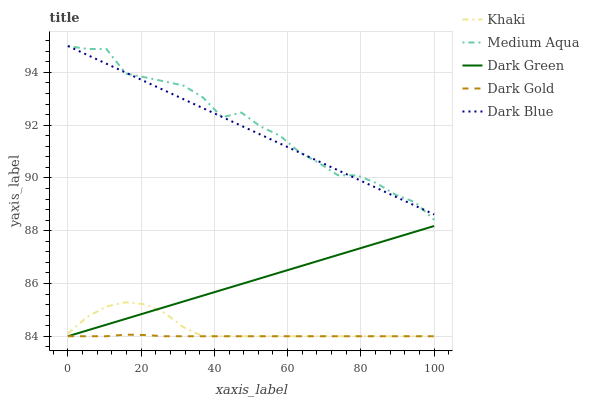Does Dark Gold have the minimum area under the curve?
Answer yes or no. Yes. Does Medium Aqua have the maximum area under the curve?
Answer yes or no. Yes. Does Khaki have the minimum area under the curve?
Answer yes or no. No. Does Khaki have the maximum area under the curve?
Answer yes or no. No. Is Dark Green the smoothest?
Answer yes or no. Yes. Is Medium Aqua the roughest?
Answer yes or no. Yes. Is Khaki the smoothest?
Answer yes or no. No. Is Khaki the roughest?
Answer yes or no. No. Does Khaki have the lowest value?
Answer yes or no. Yes. Does Medium Aqua have the lowest value?
Answer yes or no. No. Does Medium Aqua have the highest value?
Answer yes or no. Yes. Does Khaki have the highest value?
Answer yes or no. No. Is Khaki less than Medium Aqua?
Answer yes or no. Yes. Is Medium Aqua greater than Dark Green?
Answer yes or no. Yes. Does Dark Gold intersect Khaki?
Answer yes or no. Yes. Is Dark Gold less than Khaki?
Answer yes or no. No. Is Dark Gold greater than Khaki?
Answer yes or no. No. Does Khaki intersect Medium Aqua?
Answer yes or no. No. 